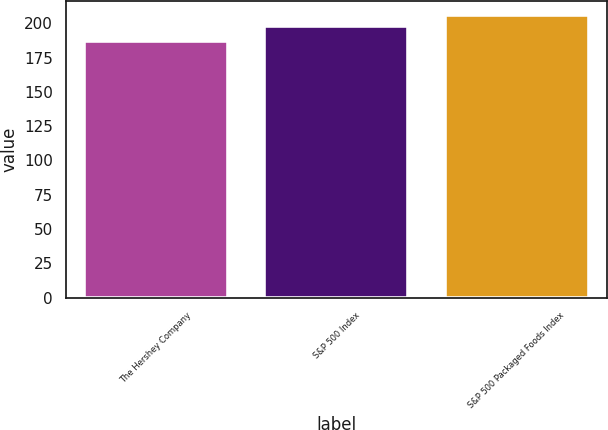<chart> <loc_0><loc_0><loc_500><loc_500><bar_chart><fcel>The Hershey Company<fcel>S&P 500 Index<fcel>S&P 500 Packaged Foods Index<nl><fcel>187<fcel>198<fcel>206<nl></chart> 